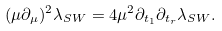Convert formula to latex. <formula><loc_0><loc_0><loc_500><loc_500>( \mu \partial _ { \mu } ) ^ { 2 } \lambda _ { S W } = 4 \mu ^ { 2 } \partial _ { t _ { 1 } } \partial _ { t _ { r } } \lambda _ { S W } .</formula> 